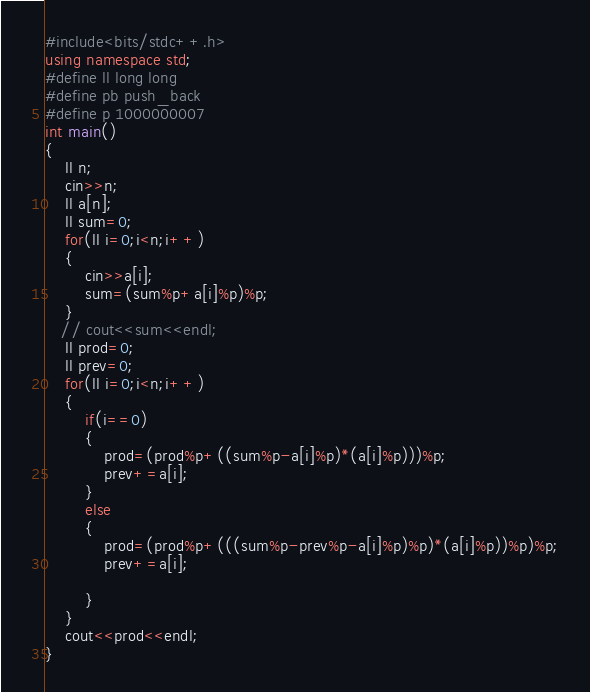<code> <loc_0><loc_0><loc_500><loc_500><_C++_>#include<bits/stdc++.h>
using namespace std;
#define ll long long
#define pb push_back
#define p 1000000007
int main()
{
    ll n;
    cin>>n;
    ll a[n];
    ll sum=0;
    for(ll i=0;i<n;i++)
    {
        cin>>a[i];
        sum=(sum%p+a[i]%p)%p;
    }
   // cout<<sum<<endl;
    ll prod=0;
    ll prev=0;
    for(ll i=0;i<n;i++)
    {
        if(i==0)
        {
            prod=(prod%p+((sum%p-a[i]%p)*(a[i]%p)))%p;
            prev+=a[i];
        }
        else
        {
            prod=(prod%p+(((sum%p-prev%p-a[i]%p)%p)*(a[i]%p))%p)%p;
            prev+=a[i];
            
        }
    }
    cout<<prod<<endl;
}</code> 